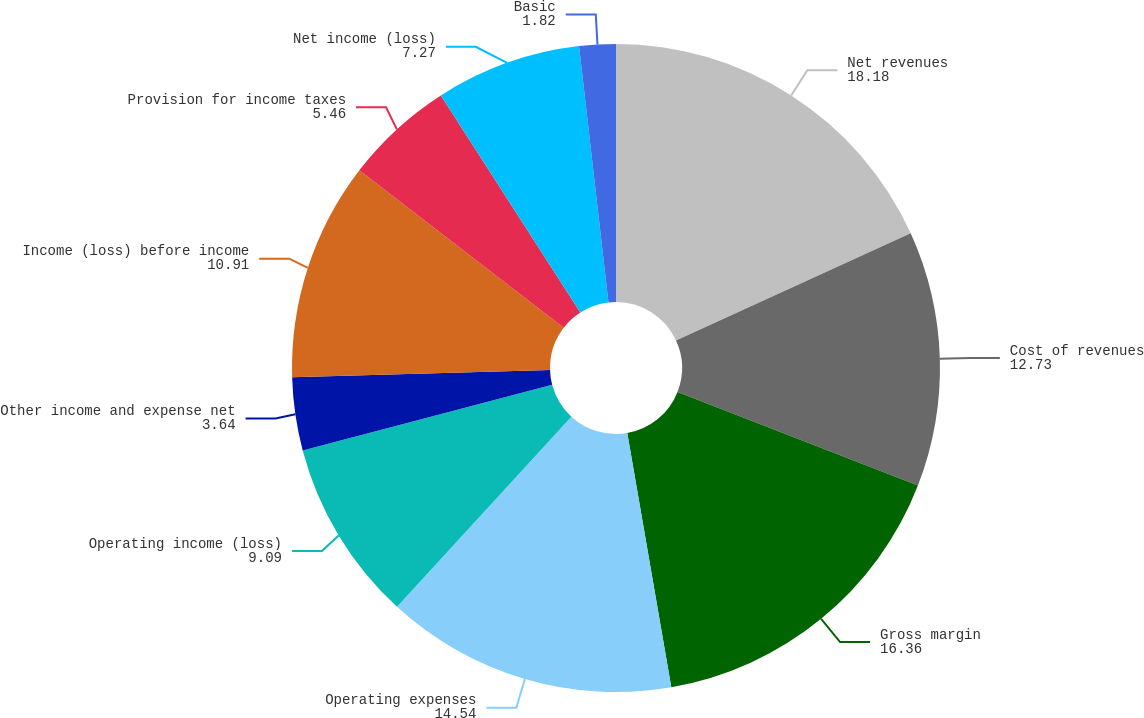Convert chart to OTSL. <chart><loc_0><loc_0><loc_500><loc_500><pie_chart><fcel>Net revenues<fcel>Cost of revenues<fcel>Gross margin<fcel>Operating expenses<fcel>Operating income (loss)<fcel>Other income and expense net<fcel>Income (loss) before income<fcel>Provision for income taxes<fcel>Net income (loss)<fcel>Basic<nl><fcel>18.18%<fcel>12.73%<fcel>16.36%<fcel>14.54%<fcel>9.09%<fcel>3.64%<fcel>10.91%<fcel>5.46%<fcel>7.27%<fcel>1.82%<nl></chart> 